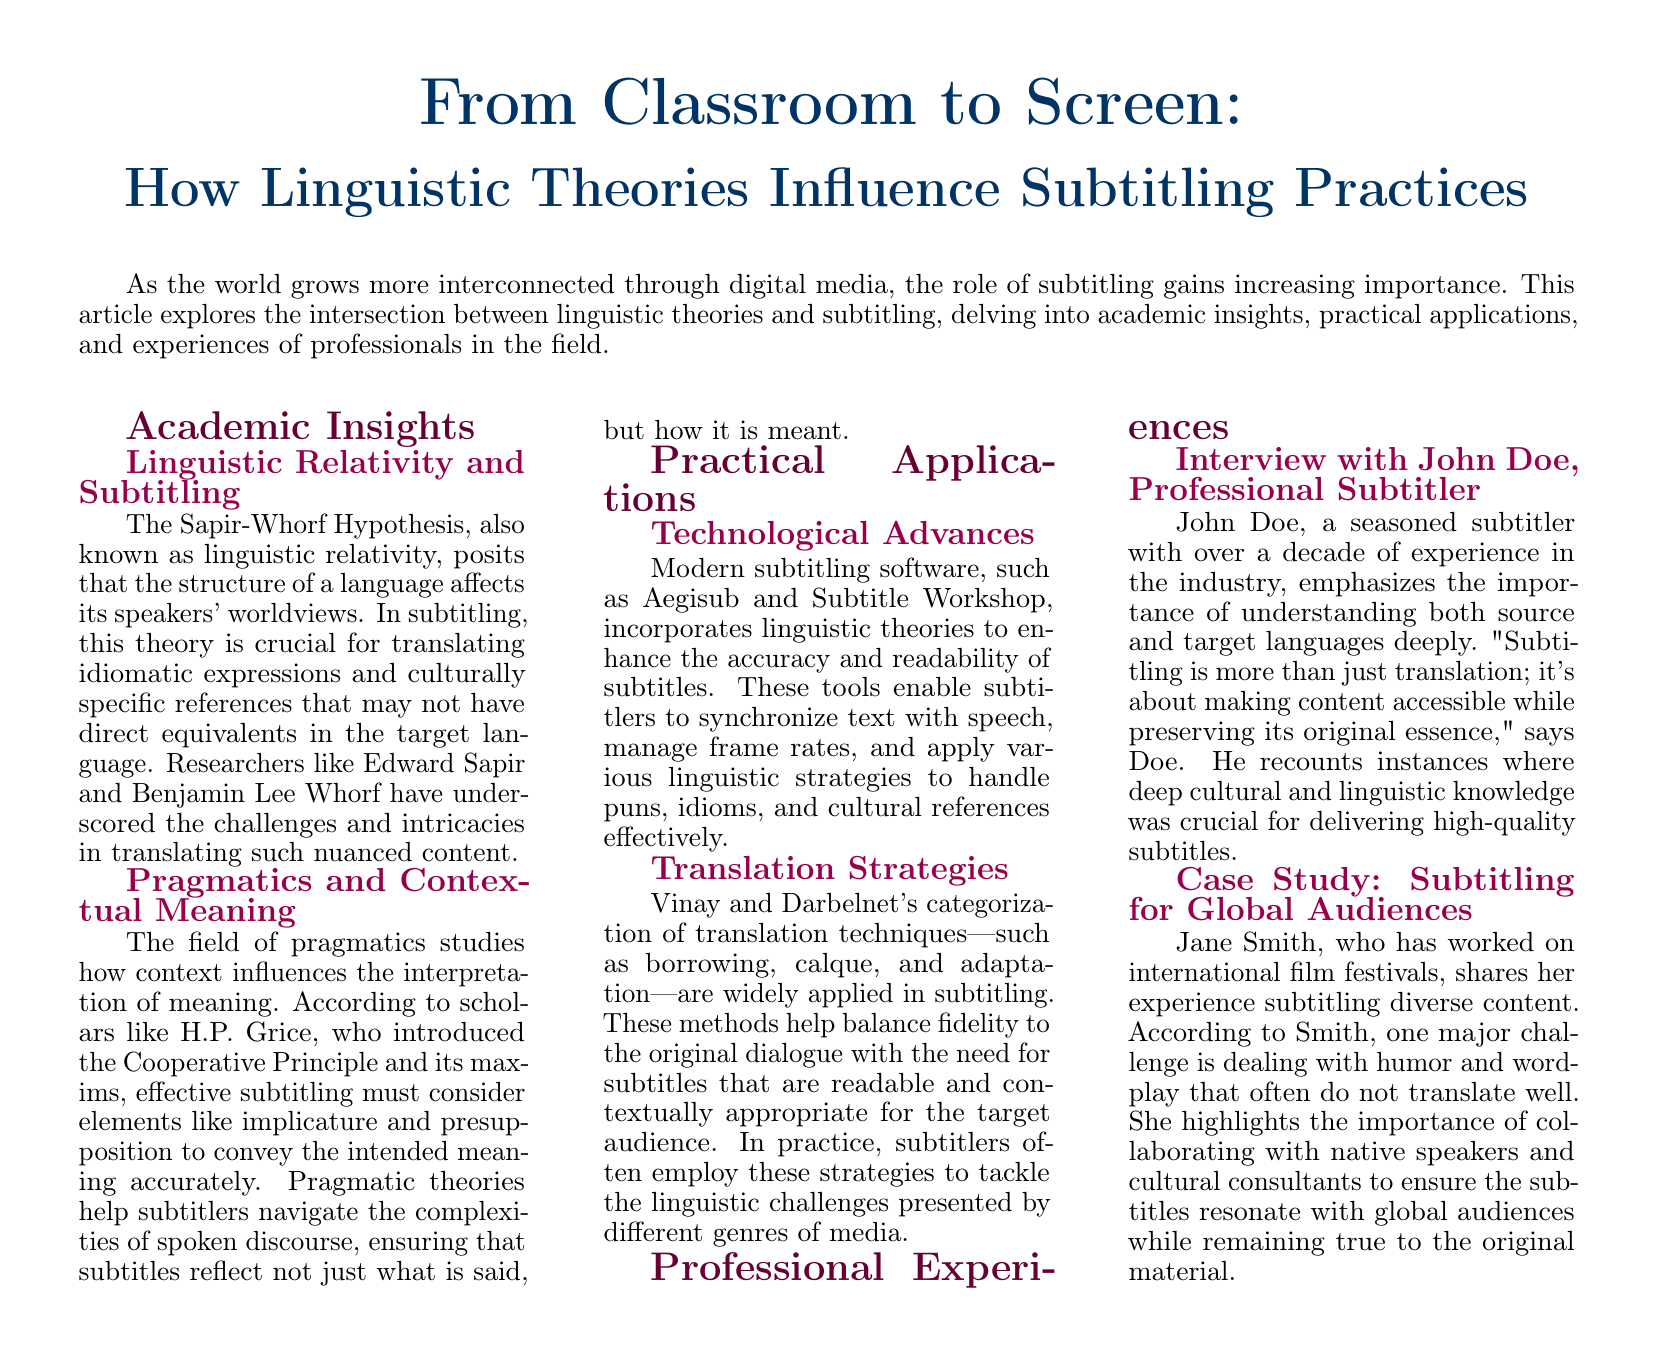What is the title of the article? The title, prominently displayed at the top of the document, is "From Classroom to Screen: How Linguistic Theories Influence Subtitling Practices."
Answer: From Classroom to Screen: How Linguistic Theories Influence Subtitling Practices Who proposed the Sapir-Whorf Hypothesis? The Sapir-Whorf Hypothesis was introduced by Edward Sapir and Benjamin Lee Whorf, as mentioned in the academic insights section.
Answer: Edward Sapir and Benjamin Lee Whorf What is one tool mentioned that improves subtitling accuracy? The document lists Aegisub and Subtitle Workshop as modern subtitling software that incorporates linguistic theories.
Answer: Aegisub What theoretical framework does H.P. Grice introduce? The Cooperative Principle and its maxims are attributed to H.P. Grice in the section discussing pragmatics.
Answer: Cooperative Principle Who is the seasoned subtitler interviewed in the article? John Doe is the professional subtitler interviewed, noted for his extensive experience in the field.
Answer: John Doe What major challenge does Jane Smith highlight in subtitling? Jane Smith discusses the difficulties of translating humor and wordplay effectively for global audiences.
Answer: Humor and wordplay What is the focus of the document? The document explores the intersection between linguistic theories and subtitling, including insights and practices.
Answer: Linguistic theories and subtitling 